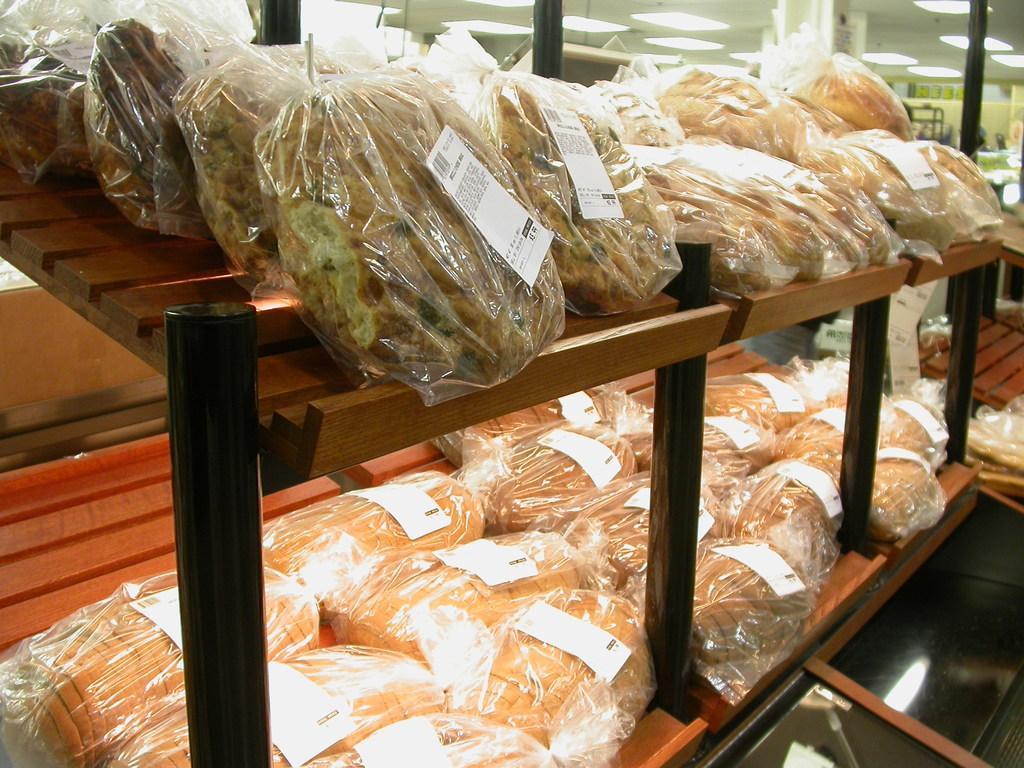In one or two sentences, can you explain what this image depicts? In this picture I can see a rack with food items packed in covers and there are stickers on it, and in the background there are lights and some other objects. 